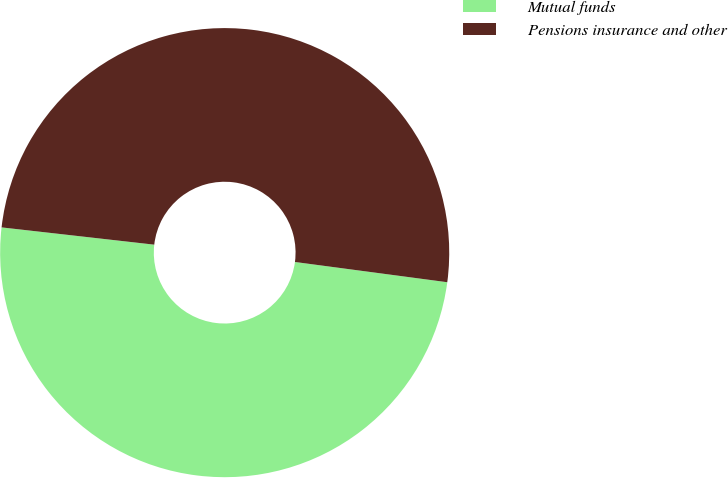Convert chart. <chart><loc_0><loc_0><loc_500><loc_500><pie_chart><fcel>Mutual funds<fcel>Pensions insurance and other<nl><fcel>49.69%<fcel>50.31%<nl></chart> 